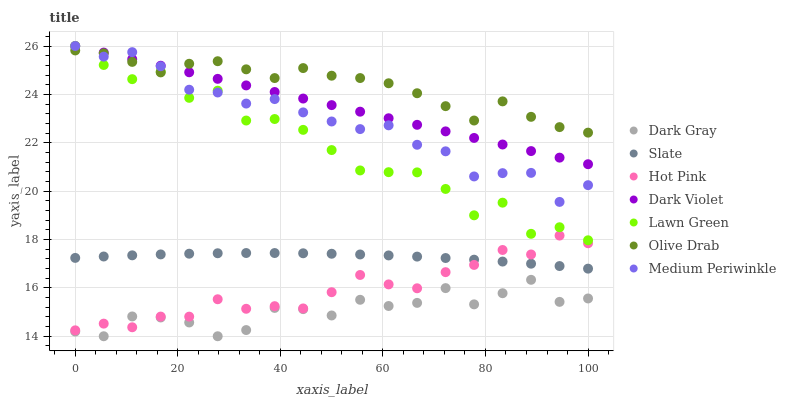Does Dark Gray have the minimum area under the curve?
Answer yes or no. Yes. Does Olive Drab have the maximum area under the curve?
Answer yes or no. Yes. Does Slate have the minimum area under the curve?
Answer yes or no. No. Does Slate have the maximum area under the curve?
Answer yes or no. No. Is Dark Violet the smoothest?
Answer yes or no. Yes. Is Lawn Green the roughest?
Answer yes or no. Yes. Is Slate the smoothest?
Answer yes or no. No. Is Slate the roughest?
Answer yes or no. No. Does Dark Gray have the lowest value?
Answer yes or no. Yes. Does Slate have the lowest value?
Answer yes or no. No. Does Dark Violet have the highest value?
Answer yes or no. Yes. Does Slate have the highest value?
Answer yes or no. No. Is Hot Pink less than Dark Violet?
Answer yes or no. Yes. Is Lawn Green greater than Dark Gray?
Answer yes or no. Yes. Does Hot Pink intersect Slate?
Answer yes or no. Yes. Is Hot Pink less than Slate?
Answer yes or no. No. Is Hot Pink greater than Slate?
Answer yes or no. No. Does Hot Pink intersect Dark Violet?
Answer yes or no. No. 